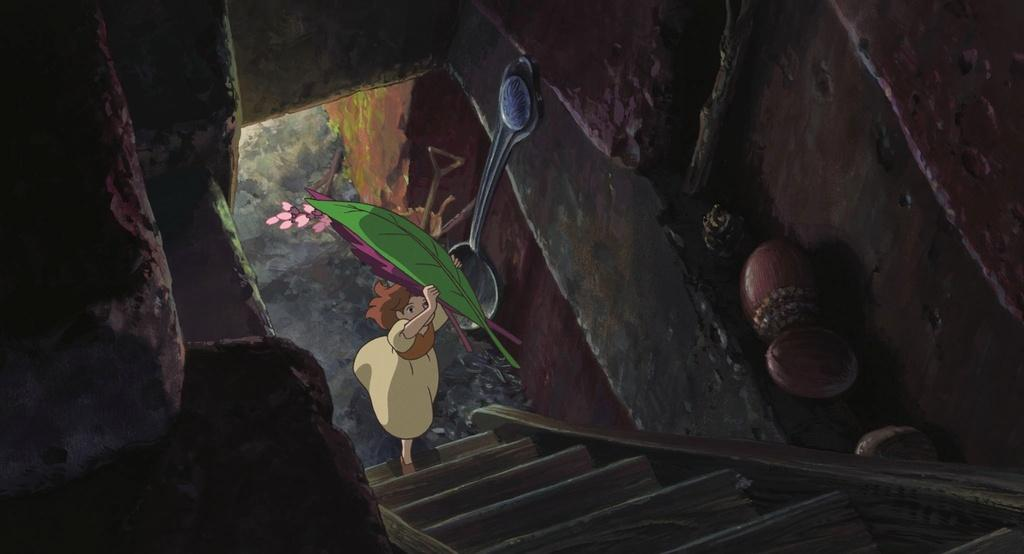What type of picture is the image? The image is an animated picture. What can be seen in the background of the image? There are walls visible in the image. What else is present in the image besides the walls? There are objects and a girl holding colorful leaves and flowers in the image. Can you describe the architectural feature in the image? There is a staircase in the image. What type of skirt is the girl wearing in the image? The girl in the image is not wearing a skirt; she is holding colorful leaves and flowers. Can you tell me how many gloves are visible in the image? There are no gloves present in the image. 